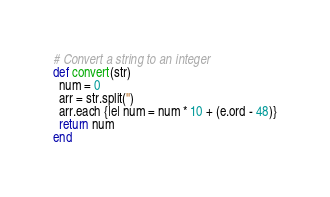Convert code to text. <code><loc_0><loc_0><loc_500><loc_500><_Ruby_># Convert a string to an integer
def convert(str)
  num = 0
  arr = str.split('')
  arr.each {|e| num = num * 10 + (e.ord - 48)}
  return num 
end
</code> 